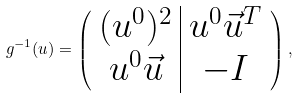<formula> <loc_0><loc_0><loc_500><loc_500>g ^ { - 1 } ( u ) = \left ( \begin{array} { c | c } ( u ^ { 0 } ) ^ { 2 } & u ^ { 0 } \vec { u } ^ { T } \\ u ^ { 0 } \vec { u } & - I \end{array} \right ) ,</formula> 